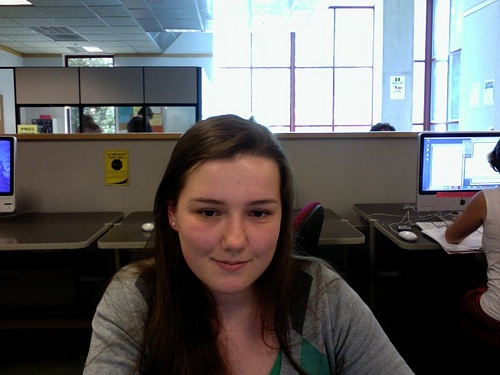Describe the objects in this image and their specific colors. I can see people in white, black, gray, brown, and maroon tones, tv in white, gray, black, and lightblue tones, people in white, gray, black, and maroon tones, chair in white, black, maroon, purple, and gray tones, and tv in white, blue, black, lightblue, and navy tones in this image. 